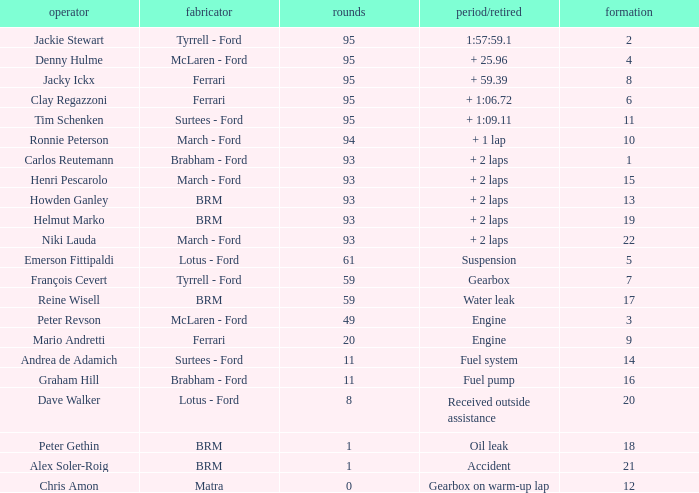What is the total number of grids for peter gethin? 18.0. 